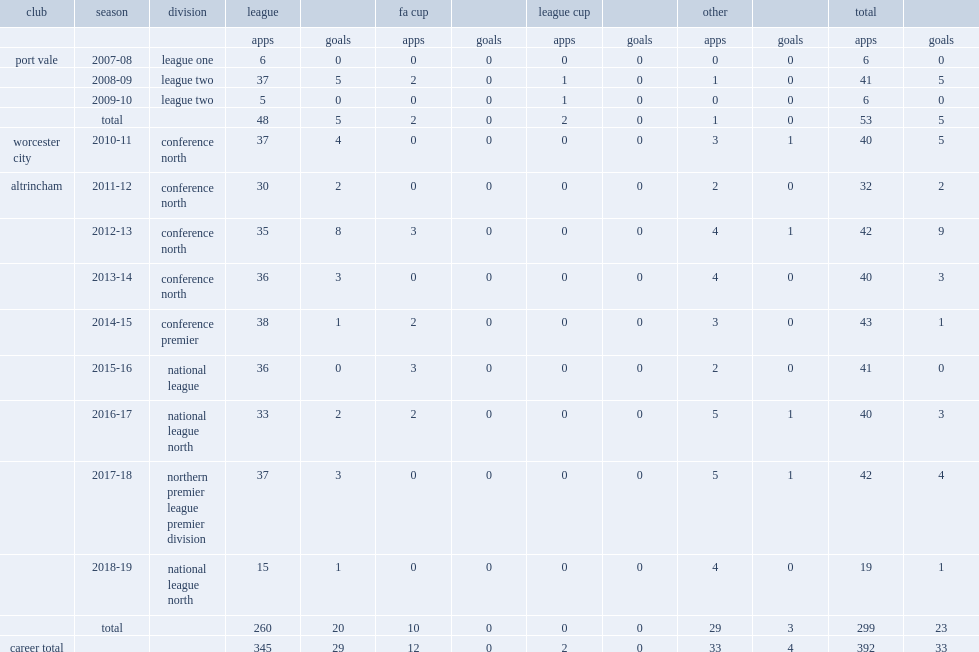How many league games did simon richman play for altrincham in 2016-17? 33.0. Parse the full table. {'header': ['club', 'season', 'division', 'league', '', 'fa cup', '', 'league cup', '', 'other', '', 'total', ''], 'rows': [['', '', '', 'apps', 'goals', 'apps', 'goals', 'apps', 'goals', 'apps', 'goals', 'apps', 'goals'], ['port vale', '2007-08', 'league one', '6', '0', '0', '0', '0', '0', '0', '0', '6', '0'], ['', '2008-09', 'league two', '37', '5', '2', '0', '1', '0', '1', '0', '41', '5'], ['', '2009-10', 'league two', '5', '0', '0', '0', '1', '0', '0', '0', '6', '0'], ['', 'total', '', '48', '5', '2', '0', '2', '0', '1', '0', '53', '5'], ['worcester city', '2010-11', 'conference north', '37', '4', '0', '0', '0', '0', '3', '1', '40', '5'], ['altrincham', '2011-12', 'conference north', '30', '2', '0', '0', '0', '0', '2', '0', '32', '2'], ['', '2012-13', 'conference north', '35', '8', '3', '0', '0', '0', '4', '1', '42', '9'], ['', '2013-14', 'conference north', '36', '3', '0', '0', '0', '0', '4', '0', '40', '3'], ['', '2014-15', 'conference premier', '38', '1', '2', '0', '0', '0', '3', '0', '43', '1'], ['', '2015-16', 'national league', '36', '0', '3', '0', '0', '0', '2', '0', '41', '0'], ['', '2016-17', 'national league north', '33', '2', '2', '0', '0', '0', '5', '1', '40', '3'], ['', '2017-18', 'northern premier league premier division', '37', '3', '0', '0', '0', '0', '5', '1', '42', '4'], ['', '2018-19', 'national league north', '15', '1', '0', '0', '0', '0', '4', '0', '19', '1'], ['', 'total', '', '260', '20', '10', '0', '0', '0', '29', '3', '299', '23'], ['career total', '', '', '345', '29', '12', '0', '2', '0', '33', '4', '392', '33']]} I'm looking to parse the entire table for insights. Could you assist me with that? {'header': ['club', 'season', 'division', 'league', '', 'fa cup', '', 'league cup', '', 'other', '', 'total', ''], 'rows': [['', '', '', 'apps', 'goals', 'apps', 'goals', 'apps', 'goals', 'apps', 'goals', 'apps', 'goals'], ['port vale', '2007-08', 'league one', '6', '0', '0', '0', '0', '0', '0', '0', '6', '0'], ['', '2008-09', 'league two', '37', '5', '2', '0', '1', '0', '1', '0', '41', '5'], ['', '2009-10', 'league two', '5', '0', '0', '0', '1', '0', '0', '0', '6', '0'], ['', 'total', '', '48', '5', '2', '0', '2', '0', '1', '0', '53', '5'], ['worcester city', '2010-11', 'conference north', '37', '4', '0', '0', '0', '0', '3', '1', '40', '5'], ['altrincham', '2011-12', 'conference north', '30', '2', '0', '0', '0', '0', '2', '0', '32', '2'], ['', '2012-13', 'conference north', '35', '8', '3', '0', '0', '0', '4', '1', '42', '9'], ['', '2013-14', 'conference north', '36', '3', '0', '0', '0', '0', '4', '0', '40', '3'], ['', '2014-15', 'conference premier', '38', '1', '2', '0', '0', '0', '3', '0', '43', '1'], ['', '2015-16', 'national league', '36', '0', '3', '0', '0', '0', '2', '0', '41', '0'], ['', '2016-17', 'national league north', '33', '2', '2', '0', '0', '0', '5', '1', '40', '3'], ['', '2017-18', 'northern premier league premier division', '37', '3', '0', '0', '0', '0', '5', '1', '42', '4'], ['', '2018-19', 'national league north', '15', '1', '0', '0', '0', '0', '4', '0', '19', '1'], ['', 'total', '', '260', '20', '10', '0', '0', '0', '29', '3', '299', '23'], ['career total', '', '', '345', '29', '12', '0', '2', '0', '33', '4', '392', '33']]} Which club did simon richman sign with altrincham in 2011 and help that club win promotion out of the conference north to the northern premier league premier division in 2017-18? Altrincham. 